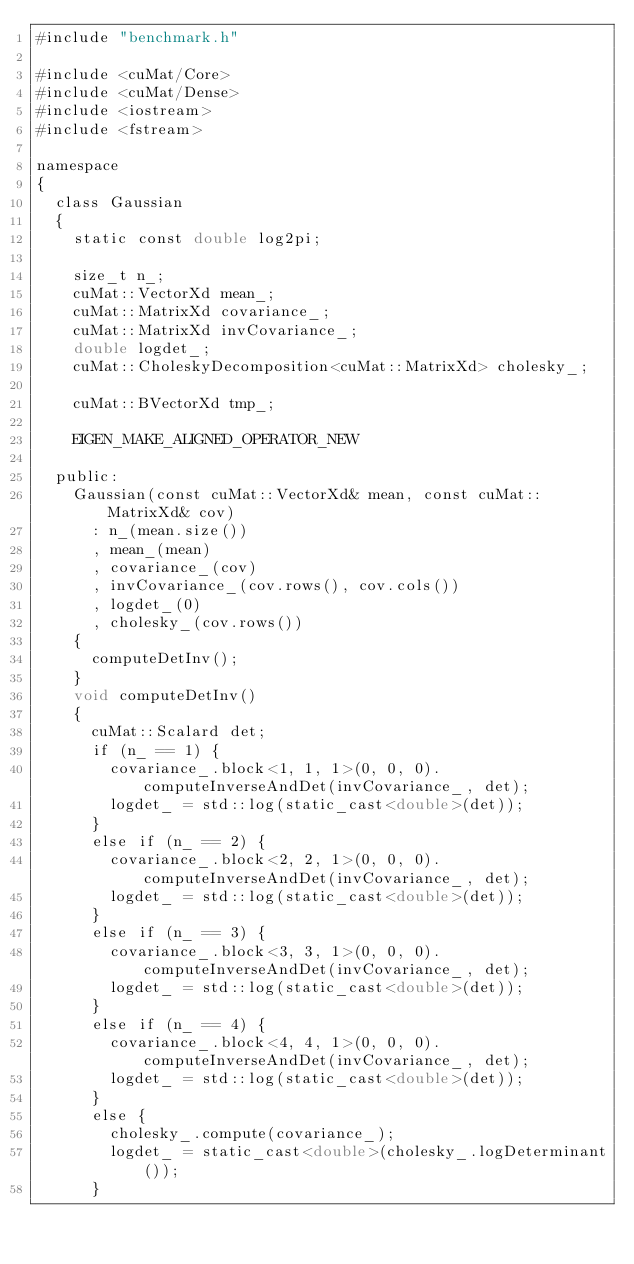<code> <loc_0><loc_0><loc_500><loc_500><_Cuda_>#include "benchmark.h"

#include <cuMat/Core>
#include <cuMat/Dense>
#include <iostream>
#include <fstream>

namespace
{
	class Gaussian
	{
		static const double log2pi;

		size_t n_;
		cuMat::VectorXd mean_;
		cuMat::MatrixXd covariance_;
		cuMat::MatrixXd invCovariance_;
		double logdet_;
		cuMat::CholeskyDecomposition<cuMat::MatrixXd> cholesky_;

		cuMat::BVectorXd tmp_;

		EIGEN_MAKE_ALIGNED_OPERATOR_NEW

	public:
		Gaussian(const cuMat::VectorXd& mean, const cuMat::MatrixXd& cov)
			: n_(mean.size())
			, mean_(mean)
			, covariance_(cov)
			, invCovariance_(cov.rows(), cov.cols())
			, logdet_(0)
			, cholesky_(cov.rows())
		{
			computeDetInv();
		}
		void computeDetInv()
		{
			cuMat::Scalard det;
			if (n_ == 1) {
				covariance_.block<1, 1, 1>(0, 0, 0).computeInverseAndDet(invCovariance_, det);
				logdet_ = std::log(static_cast<double>(det));
			}
			else if (n_ == 2) {
				covariance_.block<2, 2, 1>(0, 0, 0).computeInverseAndDet(invCovariance_, det);
				logdet_ = std::log(static_cast<double>(det));
			}
			else if (n_ == 3) {
				covariance_.block<3, 3, 1>(0, 0, 0).computeInverseAndDet(invCovariance_, det);
				logdet_ = std::log(static_cast<double>(det));
			}
			else if (n_ == 4) {
				covariance_.block<4, 4, 1>(0, 0, 0).computeInverseAndDet(invCovariance_, det);
				logdet_ = std::log(static_cast<double>(det));
			}
			else {
				cholesky_.compute(covariance_);
				logdet_ = static_cast<double>(cholesky_.logDeterminant());
			}</code> 